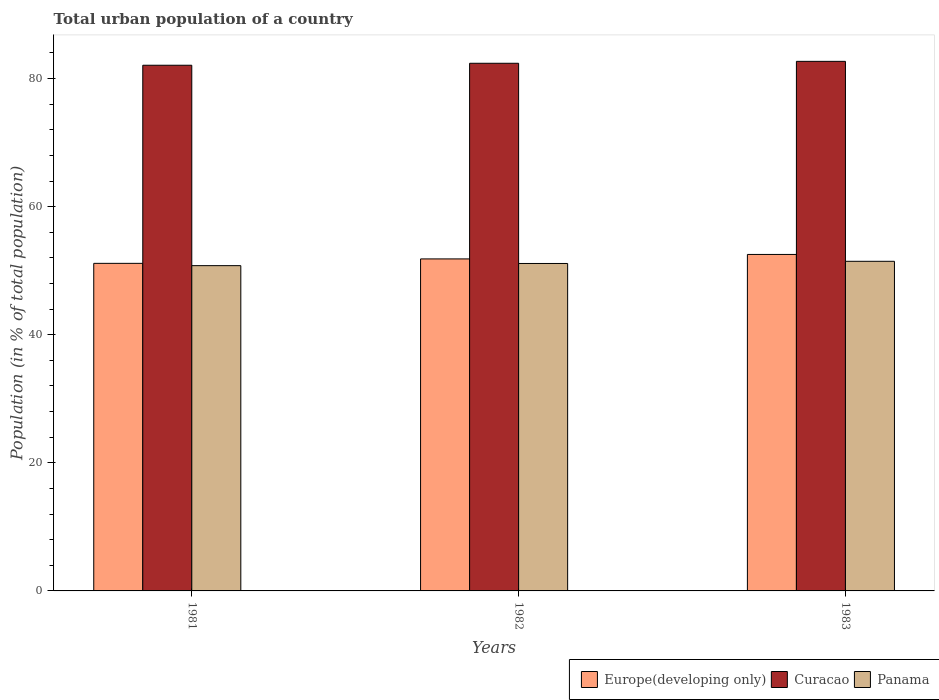How many different coloured bars are there?
Your answer should be compact. 3. Are the number of bars per tick equal to the number of legend labels?
Ensure brevity in your answer.  Yes. What is the urban population in Europe(developing only) in 1981?
Offer a very short reply. 51.15. Across all years, what is the maximum urban population in Panama?
Give a very brief answer. 51.47. Across all years, what is the minimum urban population in Europe(developing only)?
Your response must be concise. 51.15. In which year was the urban population in Panama minimum?
Ensure brevity in your answer.  1981. What is the total urban population in Europe(developing only) in the graph?
Offer a very short reply. 155.52. What is the difference between the urban population in Curacao in 1982 and that in 1983?
Your response must be concise. -0.3. What is the difference between the urban population in Panama in 1982 and the urban population in Europe(developing only) in 1983?
Offer a terse response. -1.41. What is the average urban population in Curacao per year?
Your answer should be compact. 82.38. In the year 1982, what is the difference between the urban population in Panama and urban population in Europe(developing only)?
Make the answer very short. -0.71. What is the ratio of the urban population in Europe(developing only) in 1981 to that in 1983?
Your answer should be compact. 0.97. Is the urban population in Europe(developing only) in 1982 less than that in 1983?
Give a very brief answer. Yes. Is the difference between the urban population in Panama in 1982 and 1983 greater than the difference between the urban population in Europe(developing only) in 1982 and 1983?
Your response must be concise. Yes. What is the difference between the highest and the second highest urban population in Curacao?
Offer a terse response. 0.3. What is the difference between the highest and the lowest urban population in Panama?
Your answer should be compact. 0.68. Is the sum of the urban population in Panama in 1981 and 1982 greater than the maximum urban population in Europe(developing only) across all years?
Give a very brief answer. Yes. What does the 2nd bar from the left in 1983 represents?
Your answer should be very brief. Curacao. What does the 3rd bar from the right in 1983 represents?
Keep it short and to the point. Europe(developing only). How many bars are there?
Offer a terse response. 9. Where does the legend appear in the graph?
Make the answer very short. Bottom right. What is the title of the graph?
Provide a succinct answer. Total urban population of a country. Does "Jordan" appear as one of the legend labels in the graph?
Give a very brief answer. No. What is the label or title of the Y-axis?
Ensure brevity in your answer.  Population (in % of total population). What is the Population (in % of total population) in Europe(developing only) in 1981?
Your answer should be compact. 51.15. What is the Population (in % of total population) of Curacao in 1981?
Offer a very short reply. 82.08. What is the Population (in % of total population) in Panama in 1981?
Provide a short and direct response. 50.79. What is the Population (in % of total population) of Europe(developing only) in 1982?
Offer a terse response. 51.84. What is the Population (in % of total population) in Curacao in 1982?
Make the answer very short. 82.38. What is the Population (in % of total population) in Panama in 1982?
Your answer should be compact. 51.13. What is the Population (in % of total population) in Europe(developing only) in 1983?
Offer a very short reply. 52.54. What is the Population (in % of total population) of Curacao in 1983?
Provide a succinct answer. 82.68. What is the Population (in % of total population) in Panama in 1983?
Your answer should be very brief. 51.47. Across all years, what is the maximum Population (in % of total population) in Europe(developing only)?
Your answer should be very brief. 52.54. Across all years, what is the maximum Population (in % of total population) in Curacao?
Ensure brevity in your answer.  82.68. Across all years, what is the maximum Population (in % of total population) in Panama?
Your answer should be very brief. 51.47. Across all years, what is the minimum Population (in % of total population) in Europe(developing only)?
Give a very brief answer. 51.15. Across all years, what is the minimum Population (in % of total population) of Curacao?
Offer a very short reply. 82.08. Across all years, what is the minimum Population (in % of total population) in Panama?
Provide a short and direct response. 50.79. What is the total Population (in % of total population) of Europe(developing only) in the graph?
Your answer should be very brief. 155.52. What is the total Population (in % of total population) of Curacao in the graph?
Provide a short and direct response. 247.15. What is the total Population (in % of total population) of Panama in the graph?
Provide a succinct answer. 153.38. What is the difference between the Population (in % of total population) of Europe(developing only) in 1981 and that in 1982?
Make the answer very short. -0.69. What is the difference between the Population (in % of total population) of Curacao in 1981 and that in 1982?
Give a very brief answer. -0.3. What is the difference between the Population (in % of total population) of Panama in 1981 and that in 1982?
Give a very brief answer. -0.34. What is the difference between the Population (in % of total population) of Europe(developing only) in 1981 and that in 1983?
Your answer should be compact. -1.39. What is the difference between the Population (in % of total population) in Curacao in 1981 and that in 1983?
Your answer should be compact. -0.61. What is the difference between the Population (in % of total population) of Panama in 1981 and that in 1983?
Your response must be concise. -0.68. What is the difference between the Population (in % of total population) in Europe(developing only) in 1982 and that in 1983?
Keep it short and to the point. -0.7. What is the difference between the Population (in % of total population) in Curacao in 1982 and that in 1983?
Offer a terse response. -0.3. What is the difference between the Population (in % of total population) of Panama in 1982 and that in 1983?
Ensure brevity in your answer.  -0.34. What is the difference between the Population (in % of total population) of Europe(developing only) in 1981 and the Population (in % of total population) of Curacao in 1982?
Make the answer very short. -31.24. What is the difference between the Population (in % of total population) of Europe(developing only) in 1981 and the Population (in % of total population) of Panama in 1982?
Your answer should be very brief. 0.02. What is the difference between the Population (in % of total population) of Curacao in 1981 and the Population (in % of total population) of Panama in 1982?
Make the answer very short. 30.95. What is the difference between the Population (in % of total population) of Europe(developing only) in 1981 and the Population (in % of total population) of Curacao in 1983?
Make the answer very short. -31.54. What is the difference between the Population (in % of total population) of Europe(developing only) in 1981 and the Population (in % of total population) of Panama in 1983?
Provide a short and direct response. -0.32. What is the difference between the Population (in % of total population) of Curacao in 1981 and the Population (in % of total population) of Panama in 1983?
Ensure brevity in your answer.  30.61. What is the difference between the Population (in % of total population) of Europe(developing only) in 1982 and the Population (in % of total population) of Curacao in 1983?
Provide a succinct answer. -30.85. What is the difference between the Population (in % of total population) of Europe(developing only) in 1982 and the Population (in % of total population) of Panama in 1983?
Your answer should be compact. 0.37. What is the difference between the Population (in % of total population) in Curacao in 1982 and the Population (in % of total population) in Panama in 1983?
Make the answer very short. 30.92. What is the average Population (in % of total population) of Europe(developing only) per year?
Provide a succinct answer. 51.84. What is the average Population (in % of total population) of Curacao per year?
Provide a succinct answer. 82.38. What is the average Population (in % of total population) in Panama per year?
Your answer should be very brief. 51.13. In the year 1981, what is the difference between the Population (in % of total population) of Europe(developing only) and Population (in % of total population) of Curacao?
Keep it short and to the point. -30.93. In the year 1981, what is the difference between the Population (in % of total population) of Europe(developing only) and Population (in % of total population) of Panama?
Give a very brief answer. 0.36. In the year 1981, what is the difference between the Population (in % of total population) of Curacao and Population (in % of total population) of Panama?
Your answer should be compact. 31.29. In the year 1982, what is the difference between the Population (in % of total population) in Europe(developing only) and Population (in % of total population) in Curacao?
Keep it short and to the point. -30.54. In the year 1982, what is the difference between the Population (in % of total population) in Europe(developing only) and Population (in % of total population) in Panama?
Make the answer very short. 0.71. In the year 1982, what is the difference between the Population (in % of total population) of Curacao and Population (in % of total population) of Panama?
Offer a terse response. 31.26. In the year 1983, what is the difference between the Population (in % of total population) in Europe(developing only) and Population (in % of total population) in Curacao?
Keep it short and to the point. -30.15. In the year 1983, what is the difference between the Population (in % of total population) of Europe(developing only) and Population (in % of total population) of Panama?
Make the answer very short. 1.07. In the year 1983, what is the difference between the Population (in % of total population) of Curacao and Population (in % of total population) of Panama?
Provide a succinct answer. 31.22. What is the ratio of the Population (in % of total population) of Europe(developing only) in 1981 to that in 1982?
Keep it short and to the point. 0.99. What is the ratio of the Population (in % of total population) in Curacao in 1981 to that in 1982?
Your answer should be very brief. 1. What is the ratio of the Population (in % of total population) in Europe(developing only) in 1981 to that in 1983?
Your answer should be very brief. 0.97. What is the ratio of the Population (in % of total population) in Europe(developing only) in 1982 to that in 1983?
Provide a succinct answer. 0.99. What is the ratio of the Population (in % of total population) in Curacao in 1982 to that in 1983?
Provide a succinct answer. 1. What is the difference between the highest and the second highest Population (in % of total population) of Europe(developing only)?
Your answer should be very brief. 0.7. What is the difference between the highest and the second highest Population (in % of total population) of Curacao?
Ensure brevity in your answer.  0.3. What is the difference between the highest and the second highest Population (in % of total population) in Panama?
Your answer should be very brief. 0.34. What is the difference between the highest and the lowest Population (in % of total population) in Europe(developing only)?
Ensure brevity in your answer.  1.39. What is the difference between the highest and the lowest Population (in % of total population) in Curacao?
Your response must be concise. 0.61. What is the difference between the highest and the lowest Population (in % of total population) of Panama?
Provide a succinct answer. 0.68. 